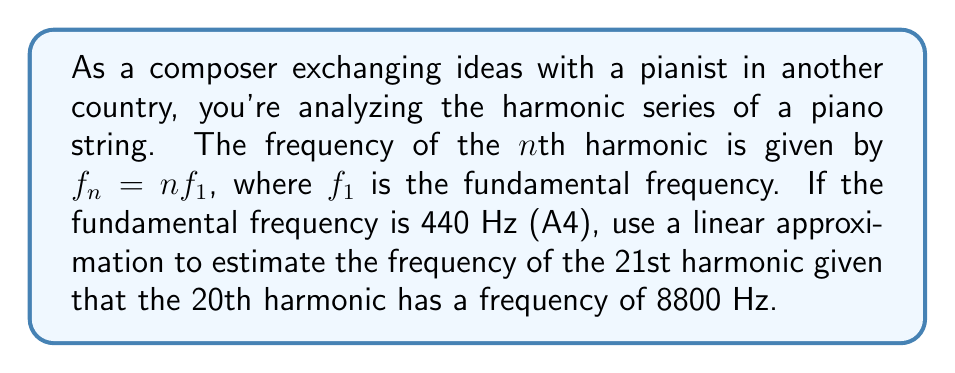Solve this math problem. Let's approach this step-by-step:

1) The harmonic series is given by $f_n = nf_1$, where $f_1 = 440$ Hz.

2) We know the 20th harmonic: $f_{20} = 20 \cdot 440 = 8800$ Hz.

3) To use a linear approximation, we can consider the function $f(n) = nf_1$ and use the point $(20, 8800)$ as our reference point.

4) The linear approximation formula is:
   $$f(n) \approx f(20) + f'(20)(n - 20)$$

5) We need to find $f'(n)$:
   $$f'(n) = \frac{d}{dn}(nf_1) = f_1 = 440$$

6) Now we can substitute into our linear approximation formula:
   $$f(21) \approx 8800 + 440(21 - 20)$$

7) Simplify:
   $$f(21) \approx 8800 + 440(1) = 8800 + 440 = 9240$$

Therefore, the linear approximation estimates the frequency of the 21st harmonic to be 9240 Hz.
Answer: 9240 Hz 